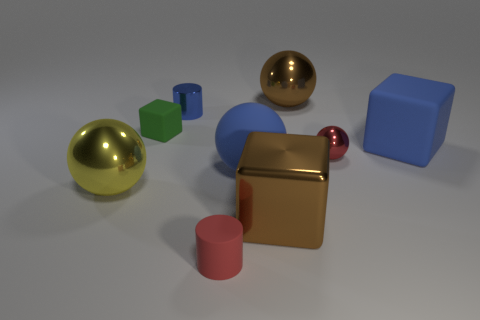Add 1 tiny matte objects. How many objects exist? 10 Subtract all cylinders. How many objects are left? 7 Add 8 tiny green balls. How many tiny green balls exist? 8 Subtract 0 green cylinders. How many objects are left? 9 Subtract all tiny red objects. Subtract all red rubber things. How many objects are left? 6 Add 9 red matte things. How many red matte things are left? 10 